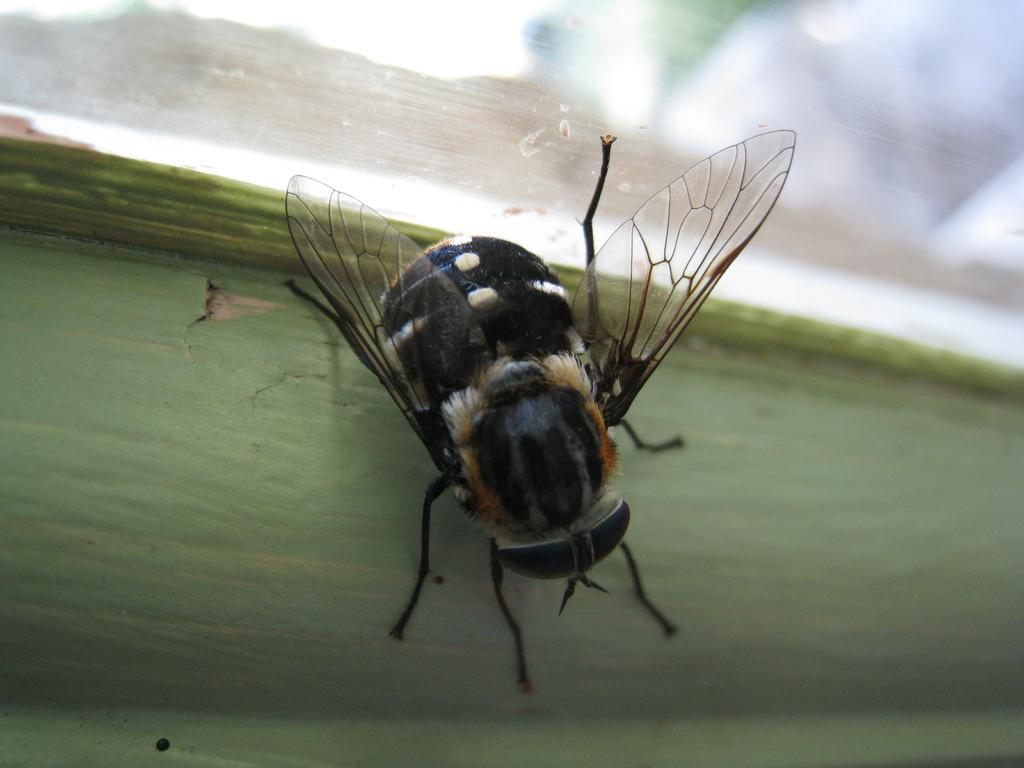What type of insect is present in the image? There is a black color Beetle insect in the image. What is the color of the other object in the image? There is a green color object in the image. What type of crime is being committed by the worm in the image? There is no worm present in the image, and therefore no crime can be committed by a worm. 